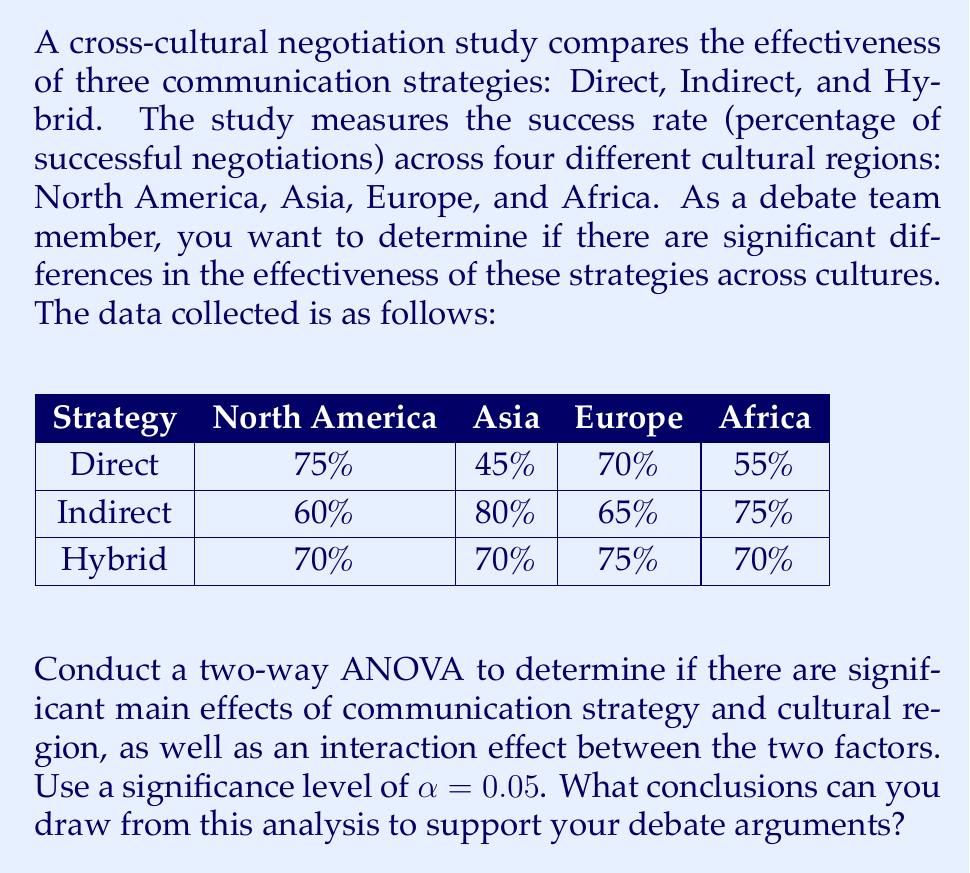Could you help me with this problem? To conduct a two-way ANOVA, we need to follow these steps:

1. Calculate the Sum of Squares (SS) for each factor and their interaction:
   - SS for Communication Strategy (A)
   - SS for Cultural Region (B)
   - SS for Interaction (AB)
   - SS for Error (within)
   - SS Total

2. Calculate the degrees of freedom (df) for each source of variation:
   - df for Communication Strategy: $a - 1 = 3 - 1 = 2$
   - df for Cultural Region: $b - 1 = 4 - 1 = 3$
   - df for Interaction: $(a-1)(b-1) = 2 \times 3 = 6$
   - df for Error: $ab(n-1) = 3 \times 4 \times (1-1) = 0$ (since we have only one observation per cell)
   - df Total: $abn - 1 = 3 \times 4 \times 1 - 1 = 11$

3. Calculate the Mean Square (MS) for each source of variation:
   MS = SS / df

4. Calculate the F-ratios:
   F = MS (source) / MS (error)

5. Compare the F-ratios to the critical F-values at $\alpha = 0.05$

Since we have only one observation per cell, we cannot calculate the error term or perform a complete ANOVA. In practice, we would need multiple observations per cell to conduct a full analysis. However, we can still calculate the main effects and interaction effect to draw some conclusions.

Let's calculate the means for each factor:

Communication Strategy means:
- Direct: $(75 + 45 + 70 + 55) / 4 = 61.25\%$
- Indirect: $(60 + 80 + 65 + 75) / 4 = 70\%$
- Hybrid: $(70 + 70 + 75 + 70) / 4 = 71.25\%$

Cultural Region means:
- North America: $(75 + 60 + 70) / 3 = 68.33\%$
- Asia: $(45 + 80 + 70) / 3 = 65\%$
- Europe: $(70 + 65 + 75) / 3 = 70\%$
- Africa: $(55 + 75 + 70) / 3 = 66.67\%$

Overall mean: $(61.25 + 70 + 71.25) / 3 = 67.5\%$

Based on these calculations, we can observe that:

1. There appears to be a main effect of Communication Strategy, with Indirect and Hybrid strategies performing better on average than the Direct strategy.

2. There seems to be a small main effect of Cultural Region, with Europe having the highest average success rate and Asia the lowest.

3. There is an apparent interaction effect between Communication Strategy and Cultural Region. For example, the Direct strategy performs well in North America and Europe but poorly in Asia, while the Indirect strategy performs better in Asia and Africa.

While we cannot determine statistical significance without a complete ANOVA, these observations can support the following debate arguments:

1. Different communication strategies have varying levels of effectiveness in cross-cultural negotiations.
2. Cultural regions may influence the overall success of negotiations, regardless of the communication strategy used.
3. The effectiveness of a particular communication strategy depends on the cultural context, suggesting that negotiators should adapt their approach based on the specific cultural region they are dealing with.
Answer: Based on the analysis, we can conclude that:

1. There is an apparent main effect of Communication Strategy, with Indirect (70%) and Hybrid (71.25%) strategies showing higher average success rates compared to the Direct strategy (61.25%).

2. There is a small main effect of Cultural Region, with Europe (70%) having the highest average success rate and Asia (65%) the lowest.

3. An interaction effect between Communication Strategy and Cultural Region is evident, indicating that the effectiveness of each strategy varies depending on the cultural context.

These findings suggest that negotiators should consider both the communication strategy and the cultural region when preparing for cross-cultural negotiations, and be prepared to adapt their approach accordingly. 